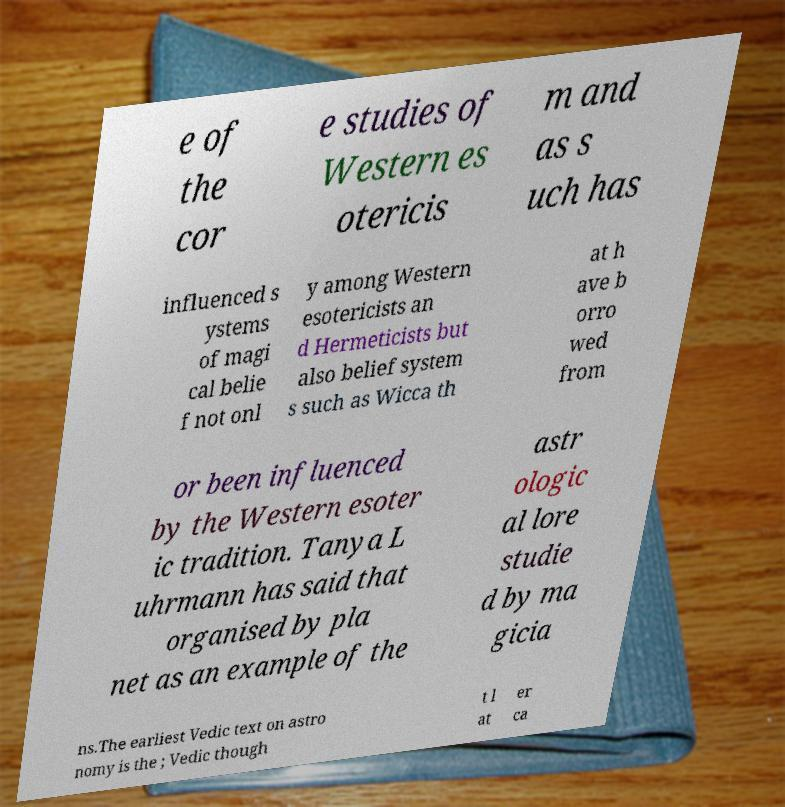Can you accurately transcribe the text from the provided image for me? e of the cor e studies of Western es otericis m and as s uch has influenced s ystems of magi cal belie f not onl y among Western esotericists an d Hermeticists but also belief system s such as Wicca th at h ave b orro wed from or been influenced by the Western esoter ic tradition. Tanya L uhrmann has said that organised by pla net as an example of the astr ologic al lore studie d by ma gicia ns.The earliest Vedic text on astro nomy is the ; Vedic though t l at er ca 